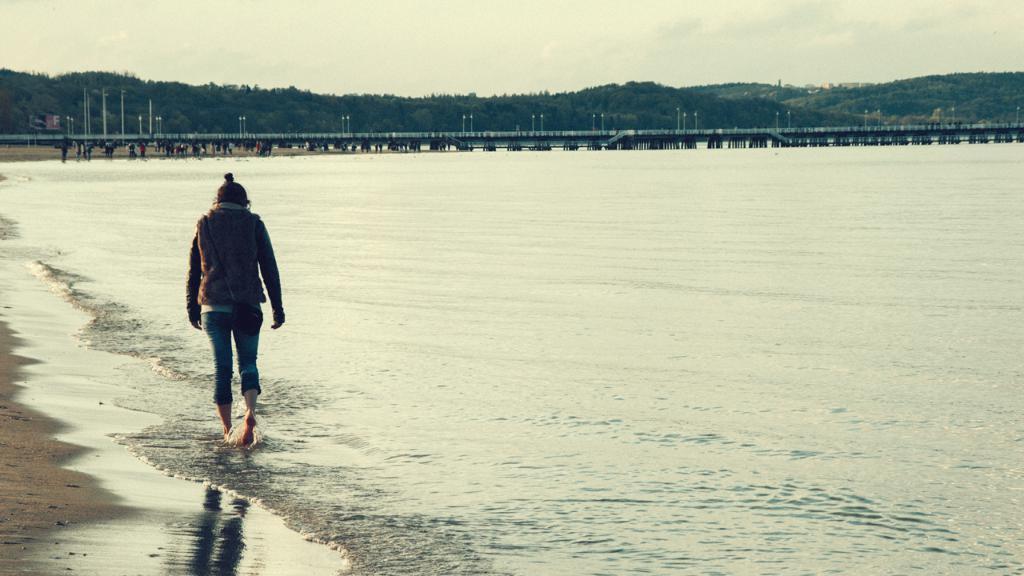Can you describe this image briefly? In this image there is one beach and on the left side there is one woman walking, and in the background there is a beach, poles, trees and some buildings. At the top of the image there is sky, and on the left side there is sand. 